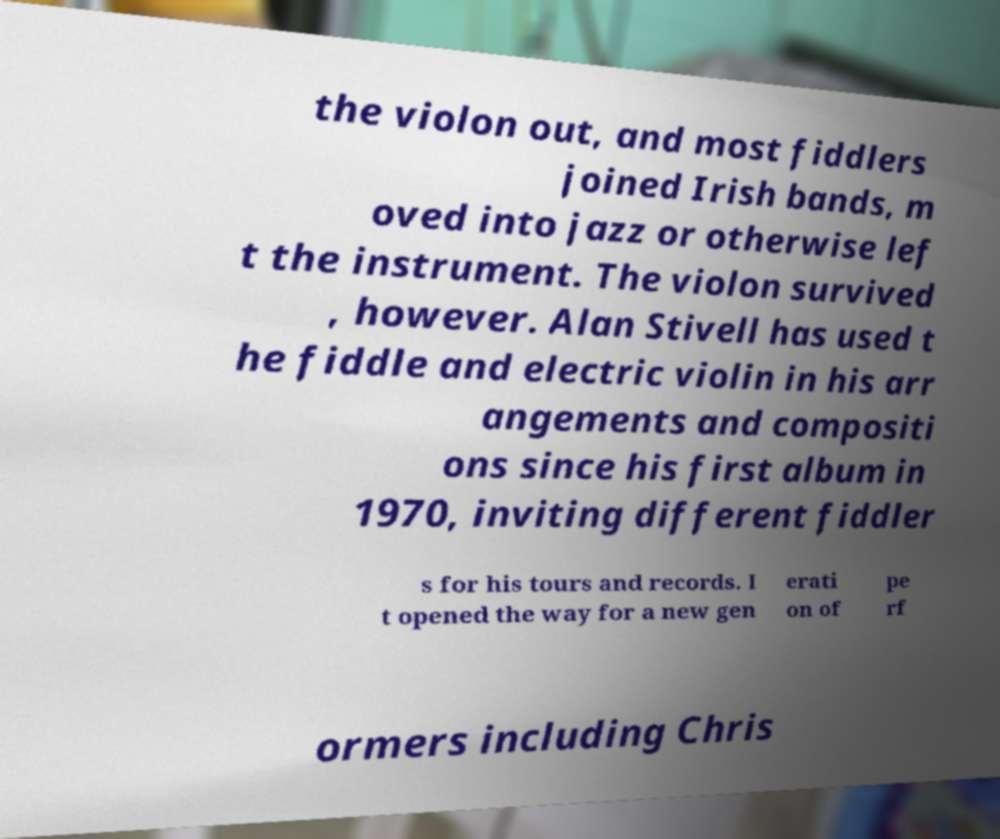Can you read and provide the text displayed in the image?This photo seems to have some interesting text. Can you extract and type it out for me? the violon out, and most fiddlers joined Irish bands, m oved into jazz or otherwise lef t the instrument. The violon survived , however. Alan Stivell has used t he fiddle and electric violin in his arr angements and compositi ons since his first album in 1970, inviting different fiddler s for his tours and records. I t opened the way for a new gen erati on of pe rf ormers including Chris 